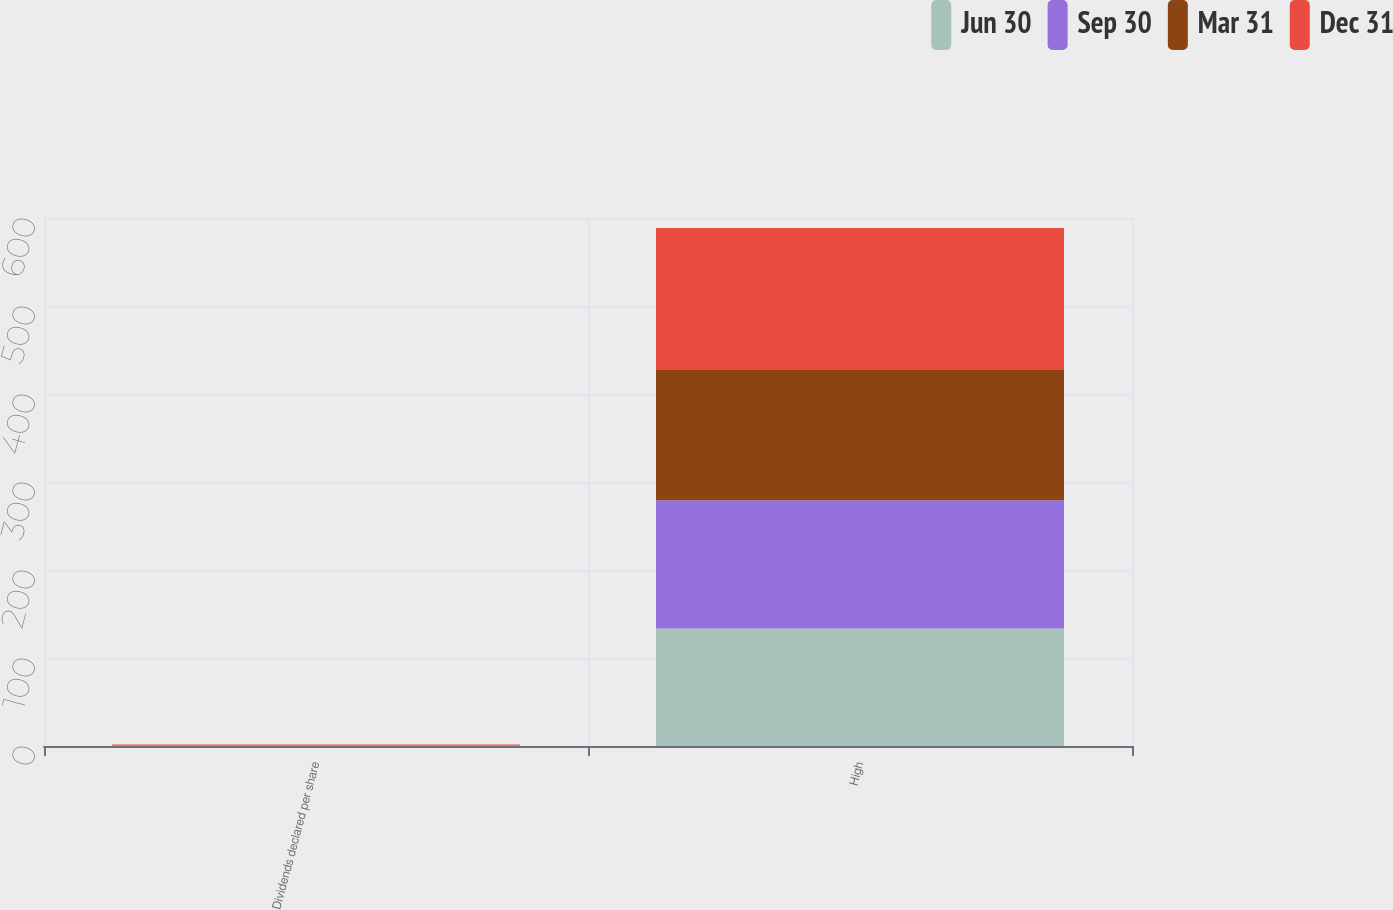<chart> <loc_0><loc_0><loc_500><loc_500><stacked_bar_chart><ecel><fcel>Dividends declared per share<fcel>High<nl><fcel>Jun 30<fcel>0.42<fcel>133.59<nl><fcel>Sep 30<fcel>0.42<fcel>145.62<nl><fcel>Mar 31<fcel>0.42<fcel>148.84<nl><fcel>Dec 31<fcel>0.47<fcel>160.62<nl></chart> 